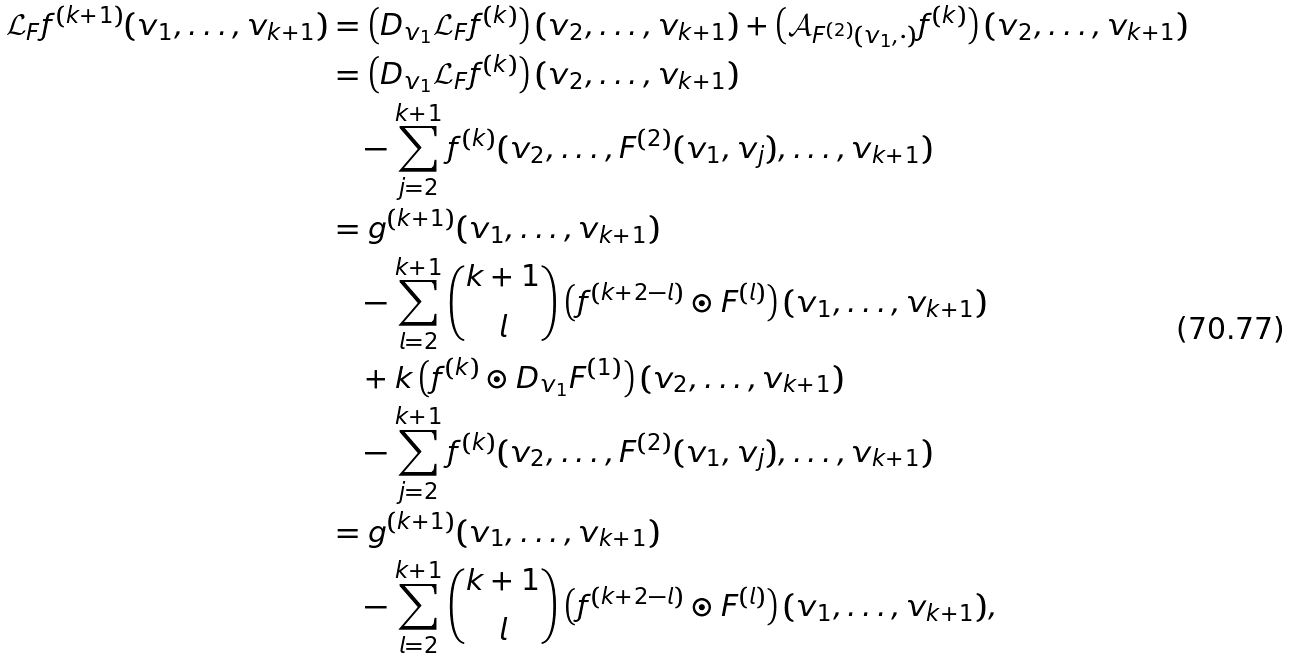Convert formula to latex. <formula><loc_0><loc_0><loc_500><loc_500>\mathcal { L } _ { F } f ^ { ( k + 1 ) } ( v _ { 1 } , \dots , v _ { k + 1 } ) & = \left ( { D } _ { v _ { 1 } } \mathcal { L } _ { F } f ^ { ( k ) } \right ) ( v _ { 2 } , \dots , v _ { k + 1 } ) + \left ( \mathcal { A } _ { F ^ { ( 2 ) } ( v _ { 1 } , \cdot ) } f ^ { ( k ) } \right ) ( v _ { 2 } , \dots , v _ { k + 1 } ) \\ & = \left ( { D } _ { v _ { 1 } } \mathcal { L } _ { F } f ^ { ( k ) } \right ) ( v _ { 2 } , \dots , v _ { k + 1 } ) \\ & \quad - \sum _ { j = 2 } ^ { k + 1 } f ^ { ( k ) } ( v _ { 2 } , \dots , F ^ { ( 2 ) } ( v _ { 1 } , v _ { j } ) , \dots , v _ { k + 1 } ) \\ & = g ^ { ( k + 1 ) } ( v _ { 1 } , \dots , v _ { k + 1 } ) \\ & \quad - \sum _ { l = 2 } ^ { k + 1 } \binom { k + 1 } { l } \left ( f ^ { ( k + 2 - l ) } \odot F ^ { ( l ) } \right ) ( v _ { 1 } , \dots , v _ { k + 1 } ) \\ & \quad + k \left ( f ^ { ( k ) } \odot { D } _ { v _ { 1 } } F ^ { ( 1 ) } \right ) ( v _ { 2 } , \dots , v _ { k + 1 } ) \\ & \quad - \sum _ { j = 2 } ^ { k + 1 } f ^ { ( k ) } ( v _ { 2 } , \dots , F ^ { ( 2 ) } ( v _ { 1 } , v _ { j } ) , \dots , v _ { k + 1 } ) \\ & = g ^ { ( k + 1 ) } ( v _ { 1 } , \dots , v _ { k + 1 } ) \\ & \quad - \sum _ { l = 2 } ^ { k + 1 } \binom { k + 1 } { l } \left ( f ^ { ( k + 2 - l ) } \odot F ^ { ( l ) } \right ) ( v _ { 1 } , \dots , v _ { k + 1 } ) ,</formula> 